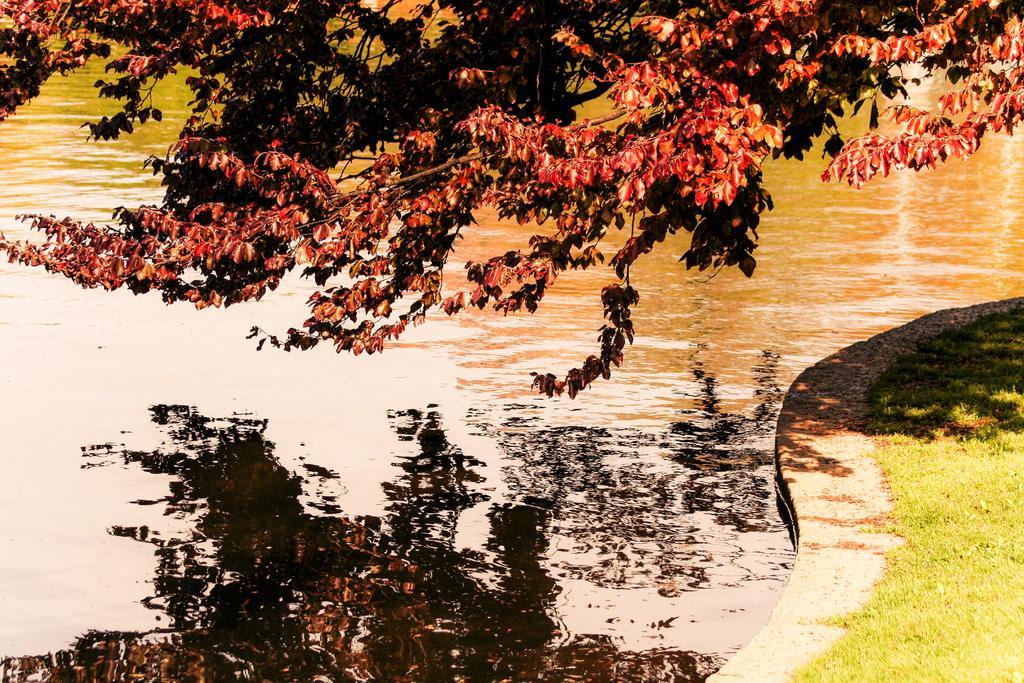Describe this image in one or two sentences. In this image we can see water. At the top there are branches of tree. On the right side there is grass on the ground. On the water there is reflection of branches of tree. 